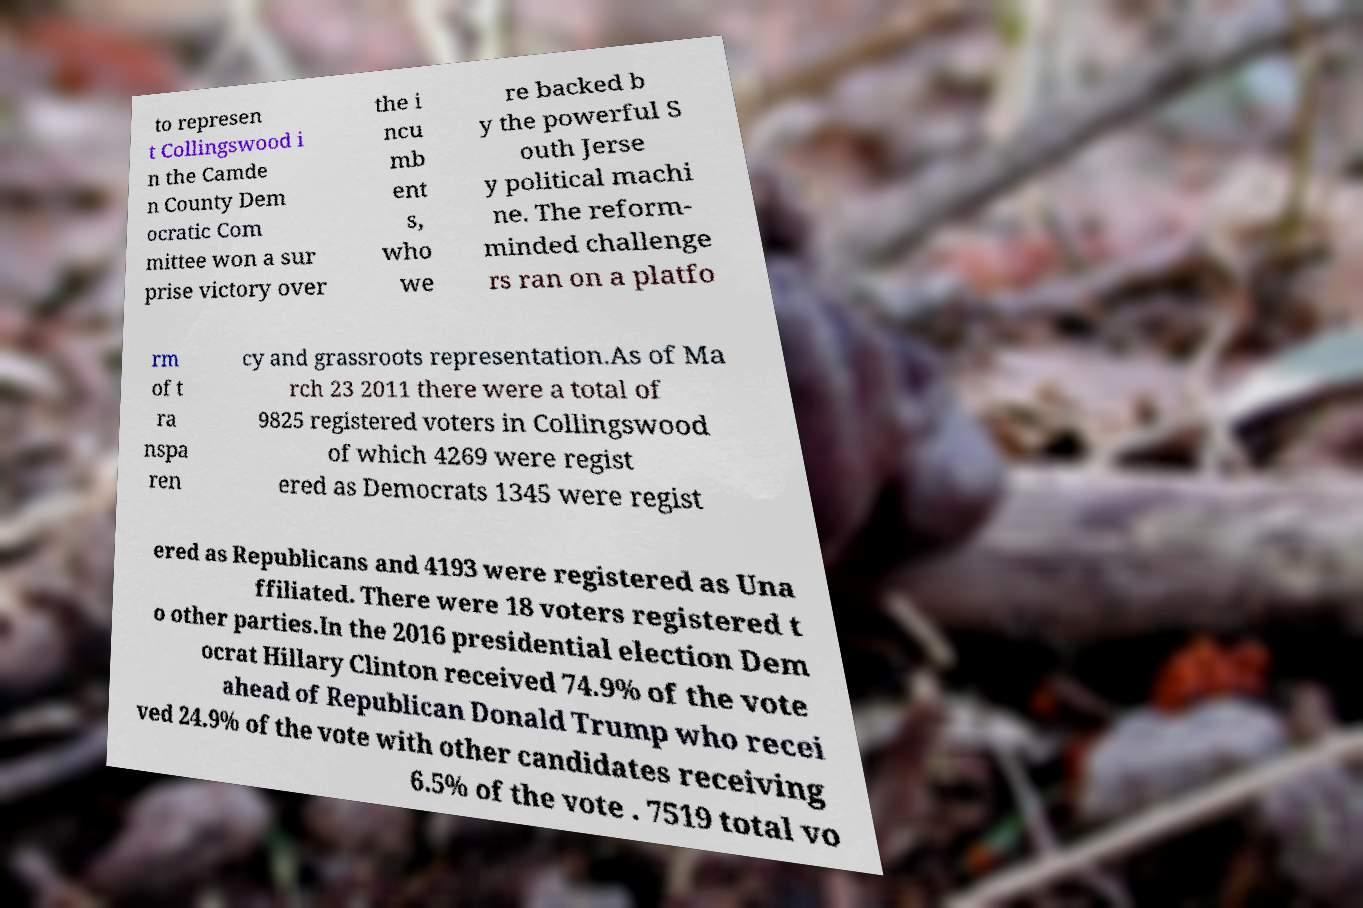There's text embedded in this image that I need extracted. Can you transcribe it verbatim? to represen t Collingswood i n the Camde n County Dem ocratic Com mittee won a sur prise victory over the i ncu mb ent s, who we re backed b y the powerful S outh Jerse y political machi ne. The reform- minded challenge rs ran on a platfo rm of t ra nspa ren cy and grassroots representation.As of Ma rch 23 2011 there were a total of 9825 registered voters in Collingswood of which 4269 were regist ered as Democrats 1345 were regist ered as Republicans and 4193 were registered as Una ffiliated. There were 18 voters registered t o other parties.In the 2016 presidential election Dem ocrat Hillary Clinton received 74.9% of the vote ahead of Republican Donald Trump who recei ved 24.9% of the vote with other candidates receiving 6.5% of the vote . 7519 total vo 